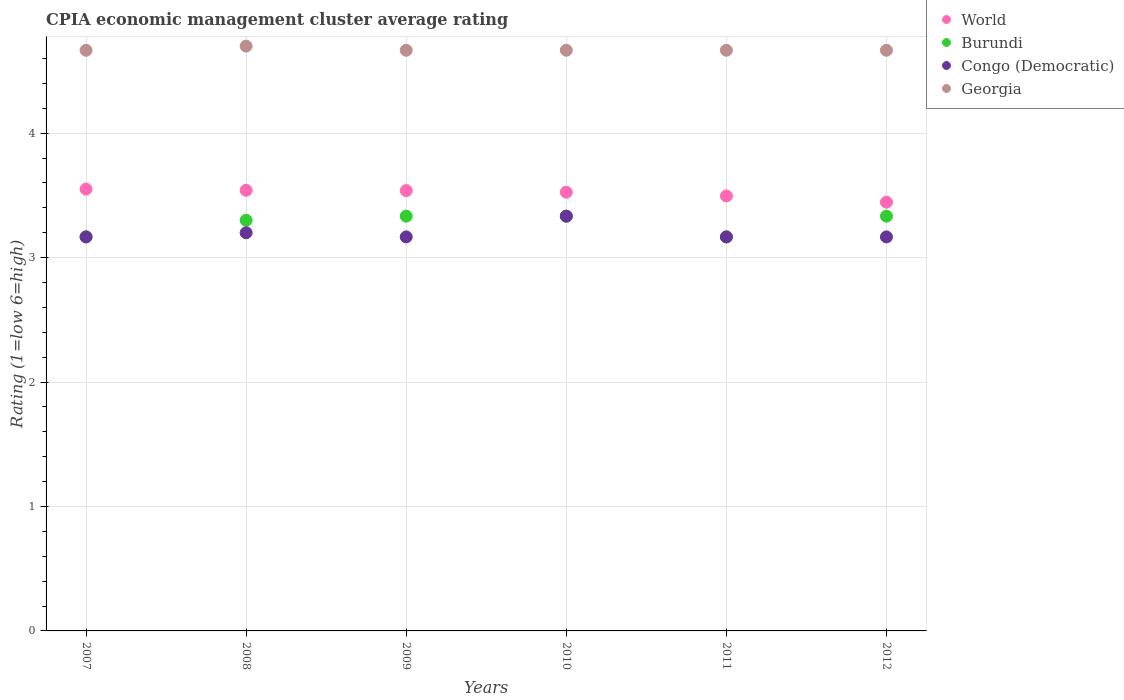Is the number of dotlines equal to the number of legend labels?
Your answer should be very brief. Yes. Across all years, what is the maximum CPIA rating in Congo (Democratic)?
Make the answer very short. 3.33. Across all years, what is the minimum CPIA rating in World?
Provide a short and direct response. 3.45. In which year was the CPIA rating in World minimum?
Your answer should be compact. 2012. What is the total CPIA rating in Burundi in the graph?
Offer a terse response. 19.63. What is the difference between the CPIA rating in Congo (Democratic) in 2010 and that in 2012?
Give a very brief answer. 0.17. What is the difference between the CPIA rating in Georgia in 2010 and the CPIA rating in World in 2012?
Offer a terse response. 1.22. What is the average CPIA rating in World per year?
Your response must be concise. 3.52. In the year 2009, what is the difference between the CPIA rating in Burundi and CPIA rating in Georgia?
Offer a terse response. -1.33. In how many years, is the CPIA rating in World greater than 0.2?
Keep it short and to the point. 6. What is the ratio of the CPIA rating in Georgia in 2007 to that in 2011?
Ensure brevity in your answer.  1. Is the difference between the CPIA rating in Burundi in 2007 and 2012 greater than the difference between the CPIA rating in Georgia in 2007 and 2012?
Offer a very short reply. No. What is the difference between the highest and the second highest CPIA rating in World?
Your answer should be very brief. 0.01. What is the difference between the highest and the lowest CPIA rating in Burundi?
Your answer should be very brief. 0.17. In how many years, is the CPIA rating in Congo (Democratic) greater than the average CPIA rating in Congo (Democratic) taken over all years?
Ensure brevity in your answer.  1. Is it the case that in every year, the sum of the CPIA rating in Georgia and CPIA rating in Congo (Democratic)  is greater than the sum of CPIA rating in Burundi and CPIA rating in World?
Give a very brief answer. No. Is it the case that in every year, the sum of the CPIA rating in Congo (Democratic) and CPIA rating in World  is greater than the CPIA rating in Burundi?
Ensure brevity in your answer.  Yes. Is the CPIA rating in Burundi strictly greater than the CPIA rating in World over the years?
Your response must be concise. No. How many dotlines are there?
Your answer should be very brief. 4. Are the values on the major ticks of Y-axis written in scientific E-notation?
Your answer should be very brief. No. Does the graph contain any zero values?
Give a very brief answer. No. What is the title of the graph?
Provide a succinct answer. CPIA economic management cluster average rating. Does "Morocco" appear as one of the legend labels in the graph?
Make the answer very short. No. What is the Rating (1=low 6=high) in World in 2007?
Make the answer very short. 3.55. What is the Rating (1=low 6=high) in Burundi in 2007?
Your answer should be compact. 3.17. What is the Rating (1=low 6=high) in Congo (Democratic) in 2007?
Your answer should be very brief. 3.17. What is the Rating (1=low 6=high) in Georgia in 2007?
Offer a terse response. 4.67. What is the Rating (1=low 6=high) of World in 2008?
Make the answer very short. 3.54. What is the Rating (1=low 6=high) of Burundi in 2008?
Make the answer very short. 3.3. What is the Rating (1=low 6=high) in World in 2009?
Provide a succinct answer. 3.54. What is the Rating (1=low 6=high) in Burundi in 2009?
Ensure brevity in your answer.  3.33. What is the Rating (1=low 6=high) in Congo (Democratic) in 2009?
Make the answer very short. 3.17. What is the Rating (1=low 6=high) in Georgia in 2009?
Offer a very short reply. 4.67. What is the Rating (1=low 6=high) of World in 2010?
Ensure brevity in your answer.  3.53. What is the Rating (1=low 6=high) of Burundi in 2010?
Ensure brevity in your answer.  3.33. What is the Rating (1=low 6=high) in Congo (Democratic) in 2010?
Provide a succinct answer. 3.33. What is the Rating (1=low 6=high) in Georgia in 2010?
Make the answer very short. 4.67. What is the Rating (1=low 6=high) in World in 2011?
Give a very brief answer. 3.5. What is the Rating (1=low 6=high) of Burundi in 2011?
Your answer should be very brief. 3.17. What is the Rating (1=low 6=high) in Congo (Democratic) in 2011?
Your answer should be very brief. 3.17. What is the Rating (1=low 6=high) of Georgia in 2011?
Your response must be concise. 4.67. What is the Rating (1=low 6=high) in World in 2012?
Your answer should be very brief. 3.45. What is the Rating (1=low 6=high) of Burundi in 2012?
Your response must be concise. 3.33. What is the Rating (1=low 6=high) in Congo (Democratic) in 2012?
Keep it short and to the point. 3.17. What is the Rating (1=low 6=high) in Georgia in 2012?
Give a very brief answer. 4.67. Across all years, what is the maximum Rating (1=low 6=high) in World?
Provide a succinct answer. 3.55. Across all years, what is the maximum Rating (1=low 6=high) of Burundi?
Ensure brevity in your answer.  3.33. Across all years, what is the maximum Rating (1=low 6=high) of Congo (Democratic)?
Offer a terse response. 3.33. Across all years, what is the minimum Rating (1=low 6=high) in World?
Provide a succinct answer. 3.45. Across all years, what is the minimum Rating (1=low 6=high) in Burundi?
Your answer should be very brief. 3.17. Across all years, what is the minimum Rating (1=low 6=high) of Congo (Democratic)?
Your response must be concise. 3.17. Across all years, what is the minimum Rating (1=low 6=high) in Georgia?
Provide a succinct answer. 4.67. What is the total Rating (1=low 6=high) of World in the graph?
Offer a very short reply. 21.1. What is the total Rating (1=low 6=high) in Burundi in the graph?
Your answer should be very brief. 19.63. What is the total Rating (1=low 6=high) of Georgia in the graph?
Offer a very short reply. 28.03. What is the difference between the Rating (1=low 6=high) of World in 2007 and that in 2008?
Your response must be concise. 0.01. What is the difference between the Rating (1=low 6=high) of Burundi in 2007 and that in 2008?
Keep it short and to the point. -0.13. What is the difference between the Rating (1=low 6=high) of Congo (Democratic) in 2007 and that in 2008?
Provide a short and direct response. -0.03. What is the difference between the Rating (1=low 6=high) of Georgia in 2007 and that in 2008?
Give a very brief answer. -0.03. What is the difference between the Rating (1=low 6=high) in World in 2007 and that in 2009?
Provide a short and direct response. 0.01. What is the difference between the Rating (1=low 6=high) in Congo (Democratic) in 2007 and that in 2009?
Your response must be concise. 0. What is the difference between the Rating (1=low 6=high) of World in 2007 and that in 2010?
Provide a short and direct response. 0.03. What is the difference between the Rating (1=low 6=high) of Burundi in 2007 and that in 2010?
Your answer should be very brief. -0.17. What is the difference between the Rating (1=low 6=high) in Congo (Democratic) in 2007 and that in 2010?
Your response must be concise. -0.17. What is the difference between the Rating (1=low 6=high) of Georgia in 2007 and that in 2010?
Your answer should be compact. 0. What is the difference between the Rating (1=low 6=high) of World in 2007 and that in 2011?
Offer a very short reply. 0.06. What is the difference between the Rating (1=low 6=high) in Congo (Democratic) in 2007 and that in 2011?
Give a very brief answer. 0. What is the difference between the Rating (1=low 6=high) of Georgia in 2007 and that in 2011?
Provide a succinct answer. 0. What is the difference between the Rating (1=low 6=high) in World in 2007 and that in 2012?
Offer a very short reply. 0.11. What is the difference between the Rating (1=low 6=high) of Burundi in 2007 and that in 2012?
Your answer should be very brief. -0.17. What is the difference between the Rating (1=low 6=high) in World in 2008 and that in 2009?
Provide a short and direct response. 0. What is the difference between the Rating (1=low 6=high) in Burundi in 2008 and that in 2009?
Your answer should be compact. -0.03. What is the difference between the Rating (1=low 6=high) in Congo (Democratic) in 2008 and that in 2009?
Ensure brevity in your answer.  0.03. What is the difference between the Rating (1=low 6=high) in Georgia in 2008 and that in 2009?
Ensure brevity in your answer.  0.03. What is the difference between the Rating (1=low 6=high) in World in 2008 and that in 2010?
Make the answer very short. 0.02. What is the difference between the Rating (1=low 6=high) of Burundi in 2008 and that in 2010?
Give a very brief answer. -0.03. What is the difference between the Rating (1=low 6=high) of Congo (Democratic) in 2008 and that in 2010?
Give a very brief answer. -0.13. What is the difference between the Rating (1=low 6=high) in Georgia in 2008 and that in 2010?
Ensure brevity in your answer.  0.03. What is the difference between the Rating (1=low 6=high) in World in 2008 and that in 2011?
Ensure brevity in your answer.  0.05. What is the difference between the Rating (1=low 6=high) in Burundi in 2008 and that in 2011?
Offer a terse response. 0.13. What is the difference between the Rating (1=low 6=high) in Congo (Democratic) in 2008 and that in 2011?
Ensure brevity in your answer.  0.03. What is the difference between the Rating (1=low 6=high) in Georgia in 2008 and that in 2011?
Your answer should be compact. 0.03. What is the difference between the Rating (1=low 6=high) of World in 2008 and that in 2012?
Give a very brief answer. 0.1. What is the difference between the Rating (1=low 6=high) of Burundi in 2008 and that in 2012?
Provide a short and direct response. -0.03. What is the difference between the Rating (1=low 6=high) in Congo (Democratic) in 2008 and that in 2012?
Provide a short and direct response. 0.03. What is the difference between the Rating (1=low 6=high) of World in 2009 and that in 2010?
Make the answer very short. 0.01. What is the difference between the Rating (1=low 6=high) in Burundi in 2009 and that in 2010?
Ensure brevity in your answer.  0. What is the difference between the Rating (1=low 6=high) in Georgia in 2009 and that in 2010?
Your answer should be very brief. 0. What is the difference between the Rating (1=low 6=high) in World in 2009 and that in 2011?
Offer a terse response. 0.04. What is the difference between the Rating (1=low 6=high) of Burundi in 2009 and that in 2011?
Provide a short and direct response. 0.17. What is the difference between the Rating (1=low 6=high) of Congo (Democratic) in 2009 and that in 2011?
Provide a succinct answer. 0. What is the difference between the Rating (1=low 6=high) of World in 2009 and that in 2012?
Your response must be concise. 0.09. What is the difference between the Rating (1=low 6=high) in Congo (Democratic) in 2009 and that in 2012?
Offer a very short reply. 0. What is the difference between the Rating (1=low 6=high) of World in 2010 and that in 2011?
Your answer should be very brief. 0.03. What is the difference between the Rating (1=low 6=high) in World in 2010 and that in 2012?
Provide a succinct answer. 0.08. What is the difference between the Rating (1=low 6=high) of Burundi in 2010 and that in 2012?
Provide a succinct answer. 0. What is the difference between the Rating (1=low 6=high) in Georgia in 2010 and that in 2012?
Provide a short and direct response. 0. What is the difference between the Rating (1=low 6=high) of World in 2011 and that in 2012?
Your answer should be very brief. 0.05. What is the difference between the Rating (1=low 6=high) in Congo (Democratic) in 2011 and that in 2012?
Your response must be concise. 0. What is the difference between the Rating (1=low 6=high) of World in 2007 and the Rating (1=low 6=high) of Burundi in 2008?
Keep it short and to the point. 0.25. What is the difference between the Rating (1=low 6=high) of World in 2007 and the Rating (1=low 6=high) of Congo (Democratic) in 2008?
Make the answer very short. 0.35. What is the difference between the Rating (1=low 6=high) in World in 2007 and the Rating (1=low 6=high) in Georgia in 2008?
Your answer should be very brief. -1.15. What is the difference between the Rating (1=low 6=high) of Burundi in 2007 and the Rating (1=low 6=high) of Congo (Democratic) in 2008?
Provide a succinct answer. -0.03. What is the difference between the Rating (1=low 6=high) in Burundi in 2007 and the Rating (1=low 6=high) in Georgia in 2008?
Your answer should be very brief. -1.53. What is the difference between the Rating (1=low 6=high) of Congo (Democratic) in 2007 and the Rating (1=low 6=high) of Georgia in 2008?
Your response must be concise. -1.53. What is the difference between the Rating (1=low 6=high) of World in 2007 and the Rating (1=low 6=high) of Burundi in 2009?
Offer a very short reply. 0.22. What is the difference between the Rating (1=low 6=high) in World in 2007 and the Rating (1=low 6=high) in Congo (Democratic) in 2009?
Provide a succinct answer. 0.38. What is the difference between the Rating (1=low 6=high) of World in 2007 and the Rating (1=low 6=high) of Georgia in 2009?
Your answer should be very brief. -1.12. What is the difference between the Rating (1=low 6=high) in Burundi in 2007 and the Rating (1=low 6=high) in Congo (Democratic) in 2009?
Provide a succinct answer. 0. What is the difference between the Rating (1=low 6=high) of Congo (Democratic) in 2007 and the Rating (1=low 6=high) of Georgia in 2009?
Give a very brief answer. -1.5. What is the difference between the Rating (1=low 6=high) of World in 2007 and the Rating (1=low 6=high) of Burundi in 2010?
Your answer should be very brief. 0.22. What is the difference between the Rating (1=low 6=high) of World in 2007 and the Rating (1=low 6=high) of Congo (Democratic) in 2010?
Your answer should be very brief. 0.22. What is the difference between the Rating (1=low 6=high) of World in 2007 and the Rating (1=low 6=high) of Georgia in 2010?
Offer a very short reply. -1.12. What is the difference between the Rating (1=low 6=high) in Burundi in 2007 and the Rating (1=low 6=high) in Georgia in 2010?
Give a very brief answer. -1.5. What is the difference between the Rating (1=low 6=high) in Congo (Democratic) in 2007 and the Rating (1=low 6=high) in Georgia in 2010?
Your answer should be very brief. -1.5. What is the difference between the Rating (1=low 6=high) in World in 2007 and the Rating (1=low 6=high) in Burundi in 2011?
Provide a short and direct response. 0.38. What is the difference between the Rating (1=low 6=high) of World in 2007 and the Rating (1=low 6=high) of Congo (Democratic) in 2011?
Provide a short and direct response. 0.38. What is the difference between the Rating (1=low 6=high) of World in 2007 and the Rating (1=low 6=high) of Georgia in 2011?
Offer a terse response. -1.12. What is the difference between the Rating (1=low 6=high) of Burundi in 2007 and the Rating (1=low 6=high) of Georgia in 2011?
Your answer should be very brief. -1.5. What is the difference between the Rating (1=low 6=high) in Congo (Democratic) in 2007 and the Rating (1=low 6=high) in Georgia in 2011?
Keep it short and to the point. -1.5. What is the difference between the Rating (1=low 6=high) in World in 2007 and the Rating (1=low 6=high) in Burundi in 2012?
Keep it short and to the point. 0.22. What is the difference between the Rating (1=low 6=high) of World in 2007 and the Rating (1=low 6=high) of Congo (Democratic) in 2012?
Provide a succinct answer. 0.38. What is the difference between the Rating (1=low 6=high) of World in 2007 and the Rating (1=low 6=high) of Georgia in 2012?
Make the answer very short. -1.12. What is the difference between the Rating (1=low 6=high) of Burundi in 2007 and the Rating (1=low 6=high) of Congo (Democratic) in 2012?
Your answer should be compact. 0. What is the difference between the Rating (1=low 6=high) in Congo (Democratic) in 2007 and the Rating (1=low 6=high) in Georgia in 2012?
Offer a very short reply. -1.5. What is the difference between the Rating (1=low 6=high) in World in 2008 and the Rating (1=low 6=high) in Burundi in 2009?
Make the answer very short. 0.21. What is the difference between the Rating (1=low 6=high) in World in 2008 and the Rating (1=low 6=high) in Congo (Democratic) in 2009?
Your response must be concise. 0.37. What is the difference between the Rating (1=low 6=high) of World in 2008 and the Rating (1=low 6=high) of Georgia in 2009?
Provide a succinct answer. -1.13. What is the difference between the Rating (1=low 6=high) of Burundi in 2008 and the Rating (1=low 6=high) of Congo (Democratic) in 2009?
Give a very brief answer. 0.13. What is the difference between the Rating (1=low 6=high) of Burundi in 2008 and the Rating (1=low 6=high) of Georgia in 2009?
Offer a very short reply. -1.37. What is the difference between the Rating (1=low 6=high) of Congo (Democratic) in 2008 and the Rating (1=low 6=high) of Georgia in 2009?
Offer a very short reply. -1.47. What is the difference between the Rating (1=low 6=high) of World in 2008 and the Rating (1=low 6=high) of Burundi in 2010?
Make the answer very short. 0.21. What is the difference between the Rating (1=low 6=high) of World in 2008 and the Rating (1=low 6=high) of Congo (Democratic) in 2010?
Provide a short and direct response. 0.21. What is the difference between the Rating (1=low 6=high) in World in 2008 and the Rating (1=low 6=high) in Georgia in 2010?
Provide a short and direct response. -1.13. What is the difference between the Rating (1=low 6=high) of Burundi in 2008 and the Rating (1=low 6=high) of Congo (Democratic) in 2010?
Your response must be concise. -0.03. What is the difference between the Rating (1=low 6=high) of Burundi in 2008 and the Rating (1=low 6=high) of Georgia in 2010?
Provide a succinct answer. -1.37. What is the difference between the Rating (1=low 6=high) in Congo (Democratic) in 2008 and the Rating (1=low 6=high) in Georgia in 2010?
Provide a short and direct response. -1.47. What is the difference between the Rating (1=low 6=high) in World in 2008 and the Rating (1=low 6=high) in Burundi in 2011?
Provide a succinct answer. 0.37. What is the difference between the Rating (1=low 6=high) in World in 2008 and the Rating (1=low 6=high) in Congo (Democratic) in 2011?
Keep it short and to the point. 0.37. What is the difference between the Rating (1=low 6=high) of World in 2008 and the Rating (1=low 6=high) of Georgia in 2011?
Your answer should be very brief. -1.13. What is the difference between the Rating (1=low 6=high) in Burundi in 2008 and the Rating (1=low 6=high) in Congo (Democratic) in 2011?
Keep it short and to the point. 0.13. What is the difference between the Rating (1=low 6=high) of Burundi in 2008 and the Rating (1=low 6=high) of Georgia in 2011?
Provide a short and direct response. -1.37. What is the difference between the Rating (1=low 6=high) in Congo (Democratic) in 2008 and the Rating (1=low 6=high) in Georgia in 2011?
Ensure brevity in your answer.  -1.47. What is the difference between the Rating (1=low 6=high) in World in 2008 and the Rating (1=low 6=high) in Burundi in 2012?
Your response must be concise. 0.21. What is the difference between the Rating (1=low 6=high) in World in 2008 and the Rating (1=low 6=high) in Congo (Democratic) in 2012?
Your response must be concise. 0.37. What is the difference between the Rating (1=low 6=high) in World in 2008 and the Rating (1=low 6=high) in Georgia in 2012?
Give a very brief answer. -1.13. What is the difference between the Rating (1=low 6=high) of Burundi in 2008 and the Rating (1=low 6=high) of Congo (Democratic) in 2012?
Your response must be concise. 0.13. What is the difference between the Rating (1=low 6=high) of Burundi in 2008 and the Rating (1=low 6=high) of Georgia in 2012?
Make the answer very short. -1.37. What is the difference between the Rating (1=low 6=high) in Congo (Democratic) in 2008 and the Rating (1=low 6=high) in Georgia in 2012?
Your response must be concise. -1.47. What is the difference between the Rating (1=low 6=high) in World in 2009 and the Rating (1=low 6=high) in Burundi in 2010?
Offer a very short reply. 0.21. What is the difference between the Rating (1=low 6=high) of World in 2009 and the Rating (1=low 6=high) of Congo (Democratic) in 2010?
Make the answer very short. 0.21. What is the difference between the Rating (1=low 6=high) of World in 2009 and the Rating (1=low 6=high) of Georgia in 2010?
Make the answer very short. -1.13. What is the difference between the Rating (1=low 6=high) of Burundi in 2009 and the Rating (1=low 6=high) of Congo (Democratic) in 2010?
Your answer should be very brief. 0. What is the difference between the Rating (1=low 6=high) of Burundi in 2009 and the Rating (1=low 6=high) of Georgia in 2010?
Give a very brief answer. -1.33. What is the difference between the Rating (1=low 6=high) of World in 2009 and the Rating (1=low 6=high) of Burundi in 2011?
Your answer should be compact. 0.37. What is the difference between the Rating (1=low 6=high) in World in 2009 and the Rating (1=low 6=high) in Congo (Democratic) in 2011?
Offer a very short reply. 0.37. What is the difference between the Rating (1=low 6=high) in World in 2009 and the Rating (1=low 6=high) in Georgia in 2011?
Your response must be concise. -1.13. What is the difference between the Rating (1=low 6=high) in Burundi in 2009 and the Rating (1=low 6=high) in Congo (Democratic) in 2011?
Your response must be concise. 0.17. What is the difference between the Rating (1=low 6=high) of Burundi in 2009 and the Rating (1=low 6=high) of Georgia in 2011?
Ensure brevity in your answer.  -1.33. What is the difference between the Rating (1=low 6=high) of World in 2009 and the Rating (1=low 6=high) of Burundi in 2012?
Offer a terse response. 0.21. What is the difference between the Rating (1=low 6=high) in World in 2009 and the Rating (1=low 6=high) in Congo (Democratic) in 2012?
Your answer should be compact. 0.37. What is the difference between the Rating (1=low 6=high) of World in 2009 and the Rating (1=low 6=high) of Georgia in 2012?
Your response must be concise. -1.13. What is the difference between the Rating (1=low 6=high) of Burundi in 2009 and the Rating (1=low 6=high) of Congo (Democratic) in 2012?
Make the answer very short. 0.17. What is the difference between the Rating (1=low 6=high) in Burundi in 2009 and the Rating (1=low 6=high) in Georgia in 2012?
Provide a short and direct response. -1.33. What is the difference between the Rating (1=low 6=high) in World in 2010 and the Rating (1=low 6=high) in Burundi in 2011?
Keep it short and to the point. 0.36. What is the difference between the Rating (1=low 6=high) of World in 2010 and the Rating (1=low 6=high) of Congo (Democratic) in 2011?
Provide a short and direct response. 0.36. What is the difference between the Rating (1=low 6=high) in World in 2010 and the Rating (1=low 6=high) in Georgia in 2011?
Give a very brief answer. -1.14. What is the difference between the Rating (1=low 6=high) of Burundi in 2010 and the Rating (1=low 6=high) of Congo (Democratic) in 2011?
Your answer should be very brief. 0.17. What is the difference between the Rating (1=low 6=high) of Burundi in 2010 and the Rating (1=low 6=high) of Georgia in 2011?
Provide a succinct answer. -1.33. What is the difference between the Rating (1=low 6=high) in Congo (Democratic) in 2010 and the Rating (1=low 6=high) in Georgia in 2011?
Provide a short and direct response. -1.33. What is the difference between the Rating (1=low 6=high) in World in 2010 and the Rating (1=low 6=high) in Burundi in 2012?
Your answer should be very brief. 0.19. What is the difference between the Rating (1=low 6=high) in World in 2010 and the Rating (1=low 6=high) in Congo (Democratic) in 2012?
Offer a very short reply. 0.36. What is the difference between the Rating (1=low 6=high) of World in 2010 and the Rating (1=low 6=high) of Georgia in 2012?
Your response must be concise. -1.14. What is the difference between the Rating (1=low 6=high) in Burundi in 2010 and the Rating (1=low 6=high) in Congo (Democratic) in 2012?
Provide a short and direct response. 0.17. What is the difference between the Rating (1=low 6=high) of Burundi in 2010 and the Rating (1=low 6=high) of Georgia in 2012?
Your answer should be compact. -1.33. What is the difference between the Rating (1=low 6=high) of Congo (Democratic) in 2010 and the Rating (1=low 6=high) of Georgia in 2012?
Make the answer very short. -1.33. What is the difference between the Rating (1=low 6=high) of World in 2011 and the Rating (1=low 6=high) of Burundi in 2012?
Your answer should be compact. 0.16. What is the difference between the Rating (1=low 6=high) of World in 2011 and the Rating (1=low 6=high) of Congo (Democratic) in 2012?
Provide a short and direct response. 0.33. What is the difference between the Rating (1=low 6=high) in World in 2011 and the Rating (1=low 6=high) in Georgia in 2012?
Provide a short and direct response. -1.17. What is the difference between the Rating (1=low 6=high) of Burundi in 2011 and the Rating (1=low 6=high) of Congo (Democratic) in 2012?
Offer a terse response. 0. What is the difference between the Rating (1=low 6=high) of Burundi in 2011 and the Rating (1=low 6=high) of Georgia in 2012?
Ensure brevity in your answer.  -1.5. What is the average Rating (1=low 6=high) in World per year?
Your response must be concise. 3.52. What is the average Rating (1=low 6=high) of Burundi per year?
Your response must be concise. 3.27. What is the average Rating (1=low 6=high) of Congo (Democratic) per year?
Provide a short and direct response. 3.2. What is the average Rating (1=low 6=high) in Georgia per year?
Provide a short and direct response. 4.67. In the year 2007, what is the difference between the Rating (1=low 6=high) in World and Rating (1=low 6=high) in Burundi?
Keep it short and to the point. 0.38. In the year 2007, what is the difference between the Rating (1=low 6=high) of World and Rating (1=low 6=high) of Congo (Democratic)?
Keep it short and to the point. 0.38. In the year 2007, what is the difference between the Rating (1=low 6=high) in World and Rating (1=low 6=high) in Georgia?
Give a very brief answer. -1.12. In the year 2007, what is the difference between the Rating (1=low 6=high) of Congo (Democratic) and Rating (1=low 6=high) of Georgia?
Your answer should be very brief. -1.5. In the year 2008, what is the difference between the Rating (1=low 6=high) of World and Rating (1=low 6=high) of Burundi?
Offer a very short reply. 0.24. In the year 2008, what is the difference between the Rating (1=low 6=high) in World and Rating (1=low 6=high) in Congo (Democratic)?
Make the answer very short. 0.34. In the year 2008, what is the difference between the Rating (1=low 6=high) of World and Rating (1=low 6=high) of Georgia?
Ensure brevity in your answer.  -1.16. In the year 2009, what is the difference between the Rating (1=low 6=high) of World and Rating (1=low 6=high) of Burundi?
Your answer should be compact. 0.21. In the year 2009, what is the difference between the Rating (1=low 6=high) in World and Rating (1=low 6=high) in Congo (Democratic)?
Your answer should be very brief. 0.37. In the year 2009, what is the difference between the Rating (1=low 6=high) in World and Rating (1=low 6=high) in Georgia?
Your answer should be compact. -1.13. In the year 2009, what is the difference between the Rating (1=low 6=high) in Burundi and Rating (1=low 6=high) in Congo (Democratic)?
Offer a very short reply. 0.17. In the year 2009, what is the difference between the Rating (1=low 6=high) of Burundi and Rating (1=low 6=high) of Georgia?
Your response must be concise. -1.33. In the year 2009, what is the difference between the Rating (1=low 6=high) of Congo (Democratic) and Rating (1=low 6=high) of Georgia?
Offer a very short reply. -1.5. In the year 2010, what is the difference between the Rating (1=low 6=high) of World and Rating (1=low 6=high) of Burundi?
Make the answer very short. 0.19. In the year 2010, what is the difference between the Rating (1=low 6=high) of World and Rating (1=low 6=high) of Congo (Democratic)?
Your response must be concise. 0.19. In the year 2010, what is the difference between the Rating (1=low 6=high) in World and Rating (1=low 6=high) in Georgia?
Keep it short and to the point. -1.14. In the year 2010, what is the difference between the Rating (1=low 6=high) of Burundi and Rating (1=low 6=high) of Congo (Democratic)?
Your answer should be compact. 0. In the year 2010, what is the difference between the Rating (1=low 6=high) of Burundi and Rating (1=low 6=high) of Georgia?
Your response must be concise. -1.33. In the year 2010, what is the difference between the Rating (1=low 6=high) in Congo (Democratic) and Rating (1=low 6=high) in Georgia?
Give a very brief answer. -1.33. In the year 2011, what is the difference between the Rating (1=low 6=high) of World and Rating (1=low 6=high) of Burundi?
Make the answer very short. 0.33. In the year 2011, what is the difference between the Rating (1=low 6=high) of World and Rating (1=low 6=high) of Congo (Democratic)?
Provide a succinct answer. 0.33. In the year 2011, what is the difference between the Rating (1=low 6=high) of World and Rating (1=low 6=high) of Georgia?
Offer a very short reply. -1.17. In the year 2011, what is the difference between the Rating (1=low 6=high) in Burundi and Rating (1=low 6=high) in Congo (Democratic)?
Keep it short and to the point. 0. In the year 2011, what is the difference between the Rating (1=low 6=high) of Congo (Democratic) and Rating (1=low 6=high) of Georgia?
Your response must be concise. -1.5. In the year 2012, what is the difference between the Rating (1=low 6=high) of World and Rating (1=low 6=high) of Burundi?
Ensure brevity in your answer.  0.11. In the year 2012, what is the difference between the Rating (1=low 6=high) in World and Rating (1=low 6=high) in Congo (Democratic)?
Offer a terse response. 0.28. In the year 2012, what is the difference between the Rating (1=low 6=high) in World and Rating (1=low 6=high) in Georgia?
Your answer should be very brief. -1.22. In the year 2012, what is the difference between the Rating (1=low 6=high) of Burundi and Rating (1=low 6=high) of Congo (Democratic)?
Provide a short and direct response. 0.17. In the year 2012, what is the difference between the Rating (1=low 6=high) in Burundi and Rating (1=low 6=high) in Georgia?
Keep it short and to the point. -1.33. What is the ratio of the Rating (1=low 6=high) in World in 2007 to that in 2008?
Ensure brevity in your answer.  1. What is the ratio of the Rating (1=low 6=high) of Burundi in 2007 to that in 2008?
Provide a succinct answer. 0.96. What is the ratio of the Rating (1=low 6=high) of World in 2007 to that in 2009?
Ensure brevity in your answer.  1. What is the ratio of the Rating (1=low 6=high) of Burundi in 2007 to that in 2009?
Your response must be concise. 0.95. What is the ratio of the Rating (1=low 6=high) of Georgia in 2007 to that in 2009?
Your answer should be compact. 1. What is the ratio of the Rating (1=low 6=high) of World in 2007 to that in 2010?
Keep it short and to the point. 1.01. What is the ratio of the Rating (1=low 6=high) in Burundi in 2007 to that in 2010?
Offer a very short reply. 0.95. What is the ratio of the Rating (1=low 6=high) in Congo (Democratic) in 2007 to that in 2010?
Offer a terse response. 0.95. What is the ratio of the Rating (1=low 6=high) of Georgia in 2007 to that in 2010?
Provide a succinct answer. 1. What is the ratio of the Rating (1=low 6=high) in World in 2007 to that in 2011?
Your answer should be very brief. 1.02. What is the ratio of the Rating (1=low 6=high) in Burundi in 2007 to that in 2011?
Offer a terse response. 1. What is the ratio of the Rating (1=low 6=high) in Congo (Democratic) in 2007 to that in 2011?
Provide a succinct answer. 1. What is the ratio of the Rating (1=low 6=high) in World in 2007 to that in 2012?
Your response must be concise. 1.03. What is the ratio of the Rating (1=low 6=high) in Congo (Democratic) in 2007 to that in 2012?
Your answer should be very brief. 1. What is the ratio of the Rating (1=low 6=high) of Georgia in 2007 to that in 2012?
Offer a terse response. 1. What is the ratio of the Rating (1=low 6=high) in World in 2008 to that in 2009?
Keep it short and to the point. 1. What is the ratio of the Rating (1=low 6=high) in Congo (Democratic) in 2008 to that in 2009?
Offer a very short reply. 1.01. What is the ratio of the Rating (1=low 6=high) in Georgia in 2008 to that in 2009?
Offer a very short reply. 1.01. What is the ratio of the Rating (1=low 6=high) of Georgia in 2008 to that in 2010?
Your answer should be very brief. 1.01. What is the ratio of the Rating (1=low 6=high) in Burundi in 2008 to that in 2011?
Provide a succinct answer. 1.04. What is the ratio of the Rating (1=low 6=high) in Congo (Democratic) in 2008 to that in 2011?
Your response must be concise. 1.01. What is the ratio of the Rating (1=low 6=high) in Georgia in 2008 to that in 2011?
Keep it short and to the point. 1.01. What is the ratio of the Rating (1=low 6=high) in World in 2008 to that in 2012?
Ensure brevity in your answer.  1.03. What is the ratio of the Rating (1=low 6=high) of Burundi in 2008 to that in 2012?
Ensure brevity in your answer.  0.99. What is the ratio of the Rating (1=low 6=high) in Congo (Democratic) in 2008 to that in 2012?
Your answer should be compact. 1.01. What is the ratio of the Rating (1=low 6=high) in Georgia in 2008 to that in 2012?
Make the answer very short. 1.01. What is the ratio of the Rating (1=low 6=high) of World in 2009 to that in 2010?
Offer a terse response. 1. What is the ratio of the Rating (1=low 6=high) in Congo (Democratic) in 2009 to that in 2010?
Keep it short and to the point. 0.95. What is the ratio of the Rating (1=low 6=high) of World in 2009 to that in 2011?
Provide a succinct answer. 1.01. What is the ratio of the Rating (1=low 6=high) in Burundi in 2009 to that in 2011?
Offer a very short reply. 1.05. What is the ratio of the Rating (1=low 6=high) in Congo (Democratic) in 2009 to that in 2011?
Your answer should be compact. 1. What is the ratio of the Rating (1=low 6=high) in Georgia in 2009 to that in 2011?
Keep it short and to the point. 1. What is the ratio of the Rating (1=low 6=high) of World in 2009 to that in 2012?
Give a very brief answer. 1.03. What is the ratio of the Rating (1=low 6=high) in World in 2010 to that in 2011?
Give a very brief answer. 1.01. What is the ratio of the Rating (1=low 6=high) in Burundi in 2010 to that in 2011?
Your answer should be compact. 1.05. What is the ratio of the Rating (1=low 6=high) in Congo (Democratic) in 2010 to that in 2011?
Ensure brevity in your answer.  1.05. What is the ratio of the Rating (1=low 6=high) in World in 2010 to that in 2012?
Give a very brief answer. 1.02. What is the ratio of the Rating (1=low 6=high) of Congo (Democratic) in 2010 to that in 2012?
Ensure brevity in your answer.  1.05. What is the ratio of the Rating (1=low 6=high) in World in 2011 to that in 2012?
Provide a short and direct response. 1.01. What is the ratio of the Rating (1=low 6=high) of Burundi in 2011 to that in 2012?
Offer a terse response. 0.95. What is the difference between the highest and the second highest Rating (1=low 6=high) of World?
Keep it short and to the point. 0.01. What is the difference between the highest and the second highest Rating (1=low 6=high) of Burundi?
Your answer should be compact. 0. What is the difference between the highest and the second highest Rating (1=low 6=high) of Congo (Democratic)?
Keep it short and to the point. 0.13. What is the difference between the highest and the second highest Rating (1=low 6=high) in Georgia?
Provide a succinct answer. 0.03. What is the difference between the highest and the lowest Rating (1=low 6=high) of World?
Make the answer very short. 0.11. What is the difference between the highest and the lowest Rating (1=low 6=high) of Burundi?
Your response must be concise. 0.17. 